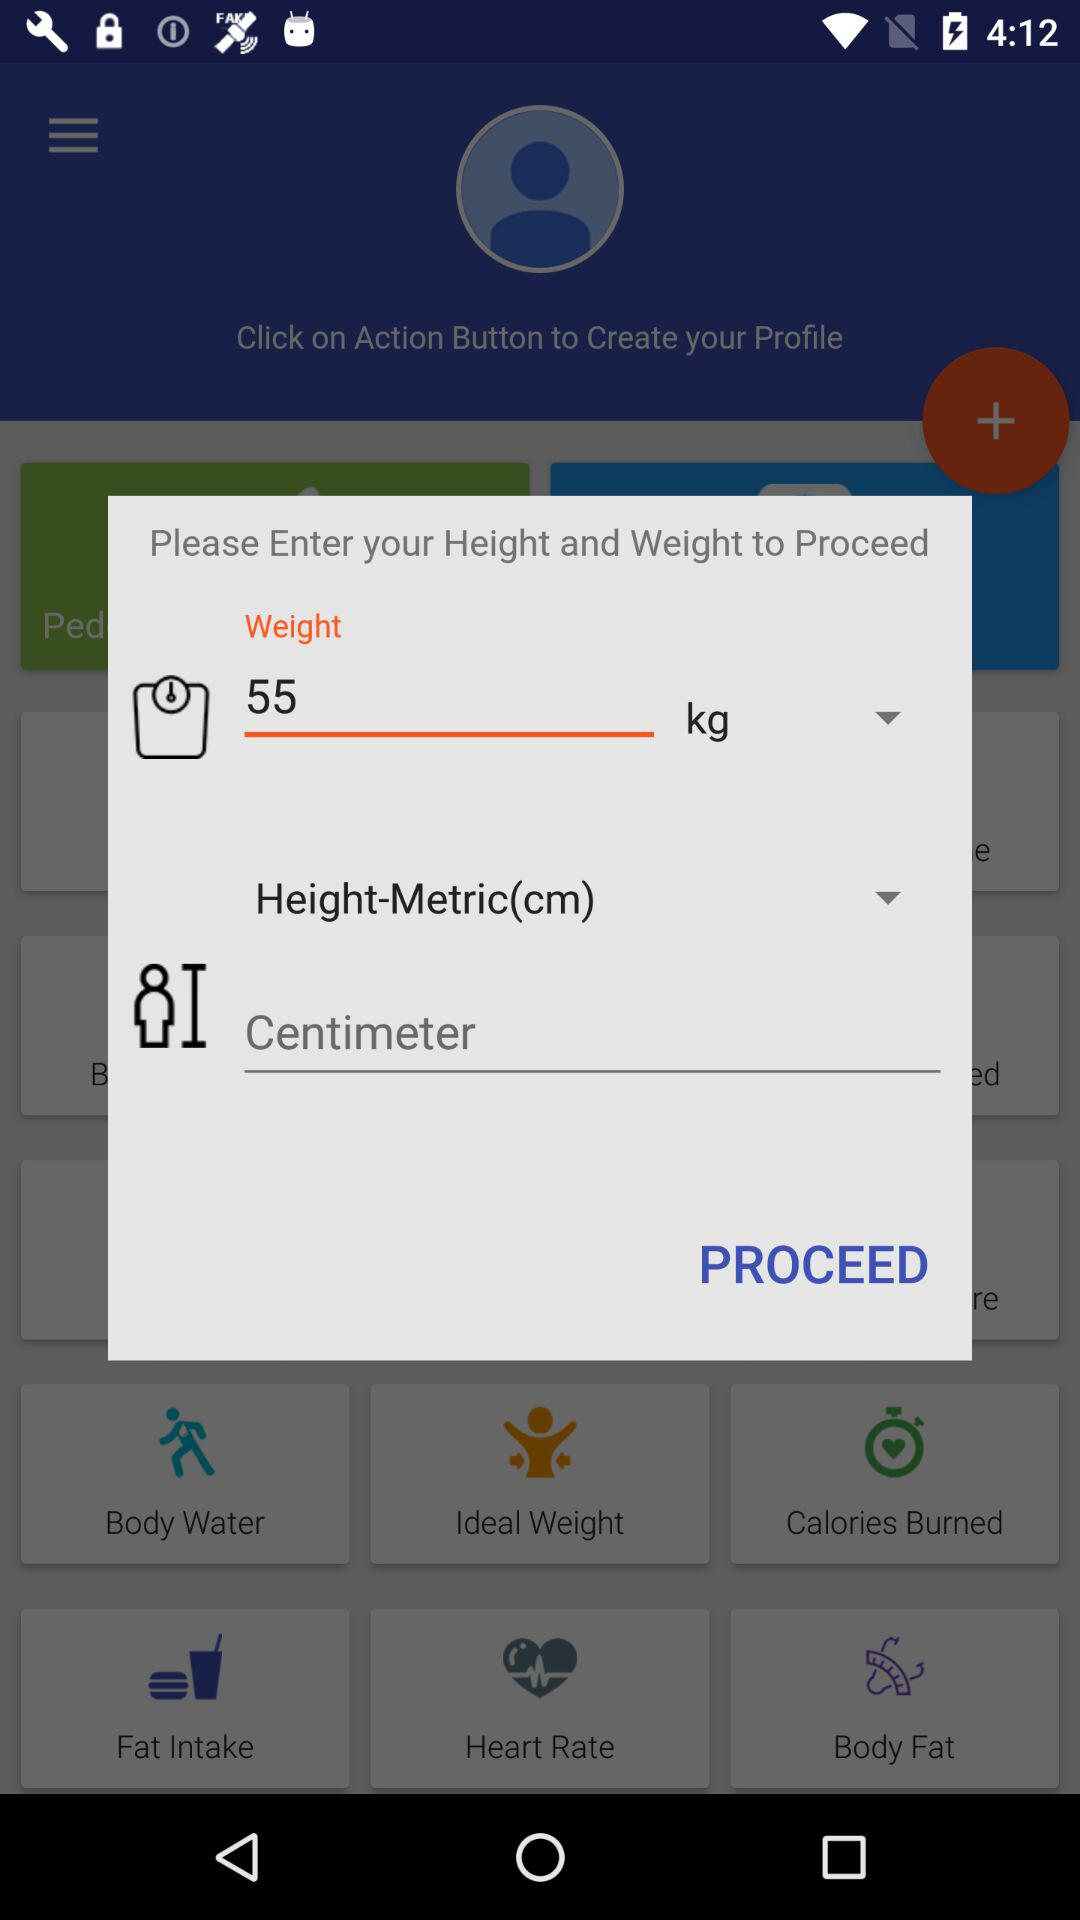What is the unit of height? The unit of height is centimeters. 